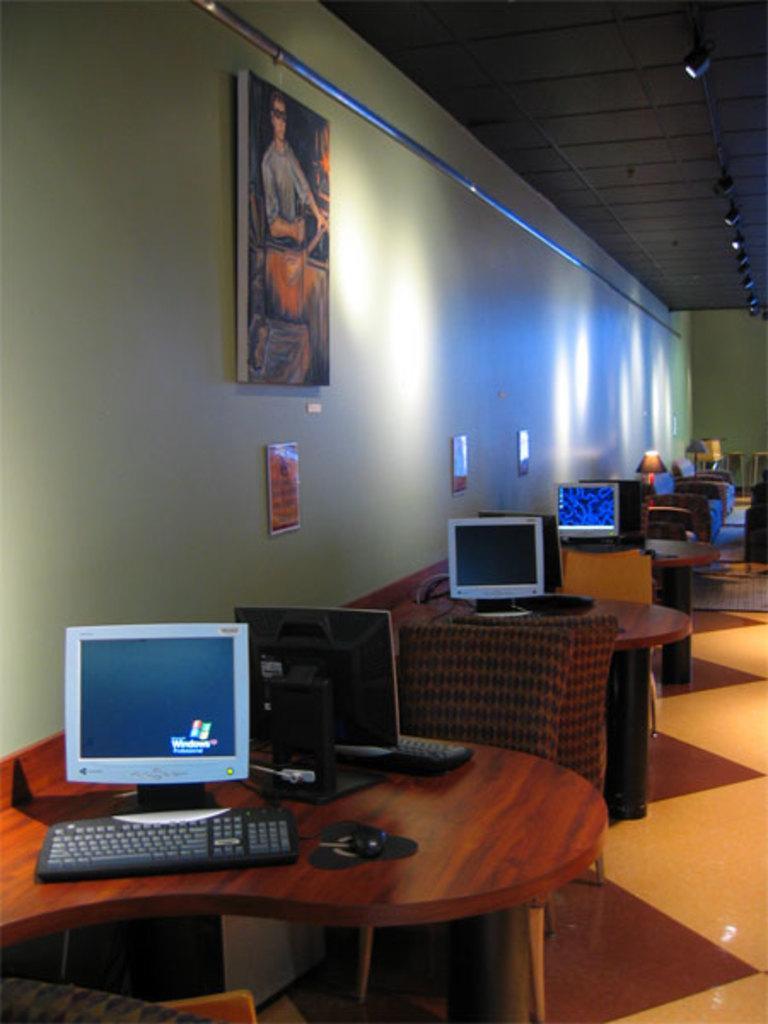Describe this image in one or two sentences. This is a wooden table. This is a computer and this is a keyboard. This is a chair. There is a photo frame onto the wall. This is a table lamp. 